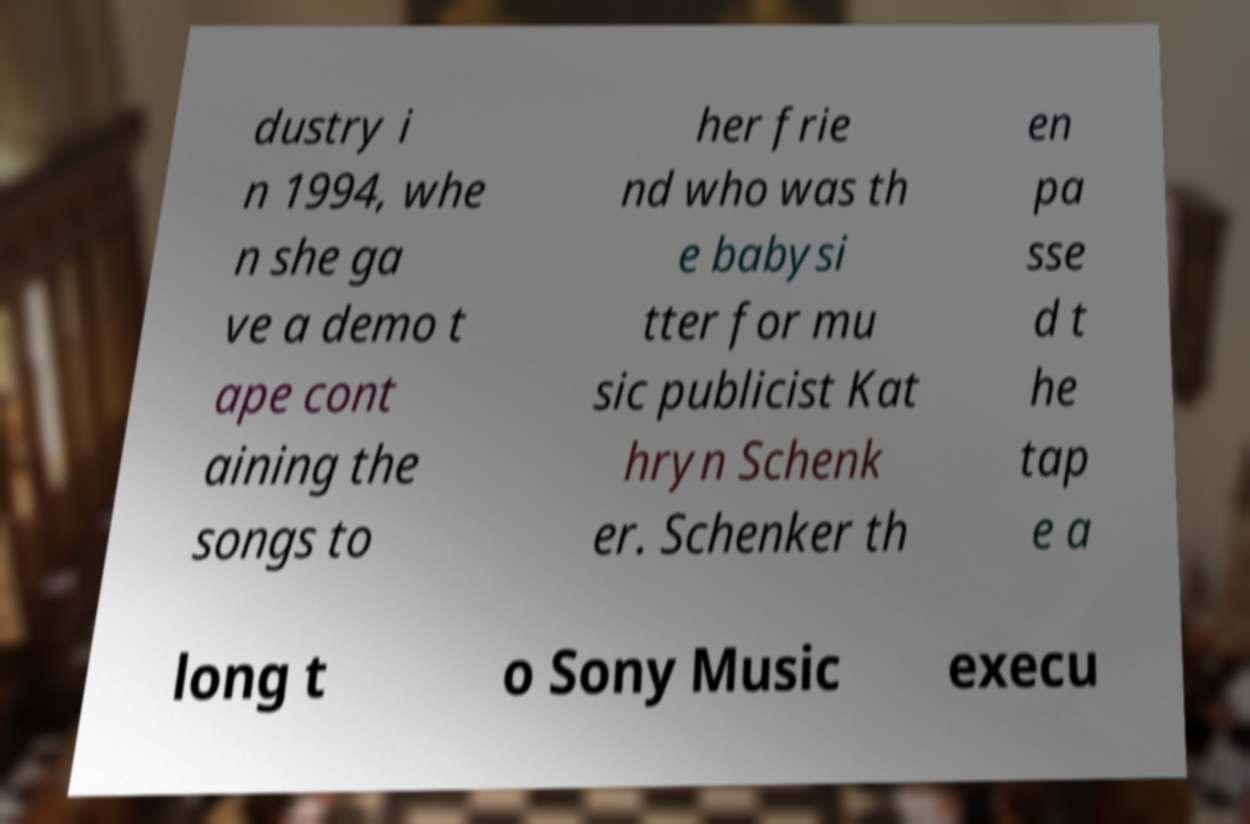Could you assist in decoding the text presented in this image and type it out clearly? dustry i n 1994, whe n she ga ve a demo t ape cont aining the songs to her frie nd who was th e babysi tter for mu sic publicist Kat hryn Schenk er. Schenker th en pa sse d t he tap e a long t o Sony Music execu 